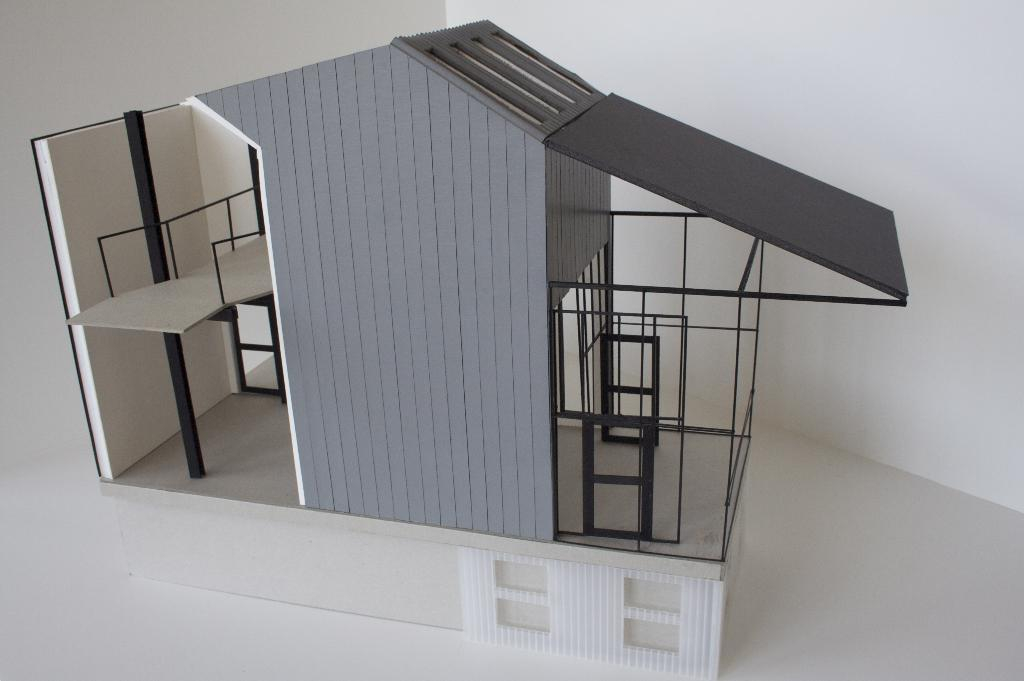What is the main subject of the image? The main subject of the image is a model building. What features can be observed on the model building? The model building has a roof and doors. What color is the background of the image? The background of the image is white in color. How many credits are required to purchase the model building in the image? There is no information about credits or purchasing in the image, as it only shows a model building with a roof and doors against a white background. 